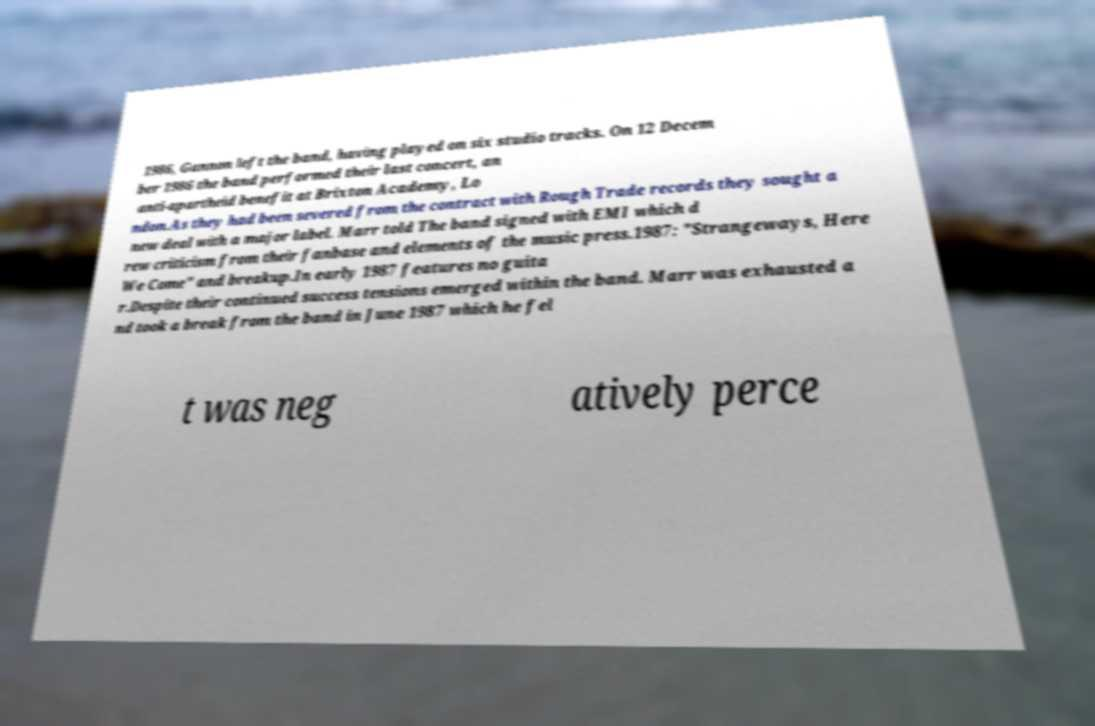Please identify and transcribe the text found in this image. 1986, Gannon left the band, having played on six studio tracks. On 12 Decem ber 1986 the band performed their last concert, an anti-apartheid benefit at Brixton Academy, Lo ndon.As they had been severed from the contract with Rough Trade records they sought a new deal with a major label. Marr told The band signed with EMI which d rew criticism from their fanbase and elements of the music press.1987: "Strangeways, Here We Come" and breakup.In early 1987 features no guita r.Despite their continued success tensions emerged within the band. Marr was exhausted a nd took a break from the band in June 1987 which he fel t was neg atively perce 